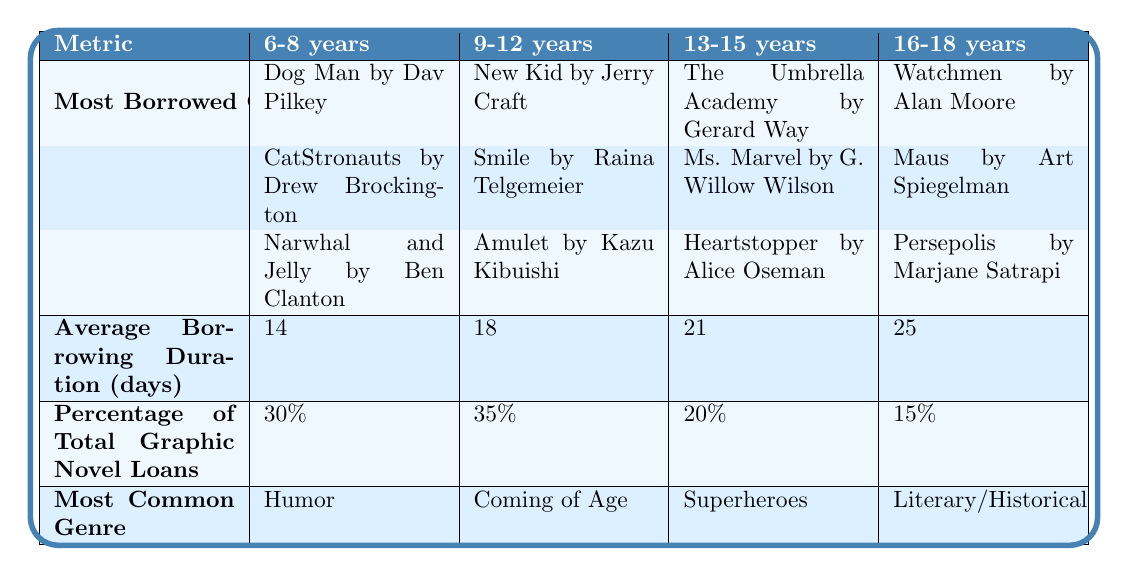What is the most borrowed graphic novel for 9-12 year-olds? According to the table, the most borrowed graphic novel for the 9-12 age group is "New Kid" by Jerry Craft.
Answer: New Kid by Jerry Craft Which age group has the highest percentage of total graphic novel loans? By observing the percentages in the table, the age group 9-12 years has the highest percentage of total graphic novel loans at 35%.
Answer: 9-12 years What is the average borrowing duration for 13-15 year-olds? The average borrowing duration for the age group 13-15 years is 21 days as stated in the table.
Answer: 21 days Is "Persepolis" the most borrowed graphic novel for the 16-18 age group? The table lists "Persepolis" as the most borrowed graphic novel for the 16-18 age group. Thus, the statement is true.
Answer: Yes What is the difference in average borrowing duration between 6-8 years and 16-18 years age groups? The average borrowing duration for 6-8 years is 14 days, and for 16-18 years, it is 25 days. The difference is 25 - 14 = 11 days.
Answer: 11 days Which age group borrows the most humor graphic novels? According to the table, the 6-8 years age group borrows the most humor graphic novels, which is their most common genre.
Answer: 6-8 years If we average the percentage of total graphic novel loans for all age groups, what would that value be? The percentages for each age group are 30%, 35%, 20%, and 15%. Summing them gives 30 + 35 + 20 + 15 = 100. Then, dividing by 4 (the number of age groups) yields an average of 100 / 4 = 25%.
Answer: 25% Which graphic novel series is the most represented in the table? By examining the entries, we see "Dog Man" and "Narwhal and Jelly" each appear once for 6-8 years, indicating no repetitions across age groups. Thus, all graphic novels are uniquely mentioned.
Answer: None (All are unique) What common genre do 13-15 year-olds prefer in graphic novels? The table indicates that the most common genre for the 13-15 year-olds is "Superheroes."
Answer: Superheroes How many days do 9-12 year-olds keep borrowed graphic novels on average? According to the table, the average borrowing duration for 9-12 year-olds is 18 days.
Answer: 18 days 